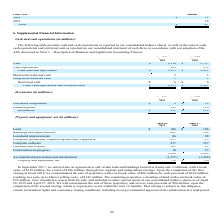According to Netapp's financial document, What was the amount of purchased components in 2019? According to the financial document, 8 (in millions). The relevant text states: "2018..." Also, What was the amount of finished goods in 2019? According to the financial document, 123 (in millions). The relevant text states: "Finished goods 123 110..." Also, What was the amount of inventories in 2018? According to the financial document, 122 (in millions). The relevant text states: "Inventories $ 131 $ 122..." Also, can you calculate: What was the change in purchased components between 2018 and 2019? Based on the calculation: 8-12, the result is -4 (in millions). This is based on the information: "Purchased components $ 8 $ 12 Purchased components $ 8 $ 12..." The key data points involved are: 12, 8. Also, can you calculate: What was the change in finished goods between 2018 and 2019? Based on the calculation: 123-110, the result is 13 (in millions). This is based on the information: "Finished goods 123 110 Finished goods 123 110..." The key data points involved are: 110, 123. Also, can you calculate: What was the percentage change in inventories between 2018 and 2019? To answer this question, I need to perform calculations using the financial data. The calculation is: (131-122)/122, which equals 7.38 (percentage). This is based on the information: "Inventories $ 131 $ 122 Inventories $ 131 $ 122..." The key data points involved are: 122, 131. 